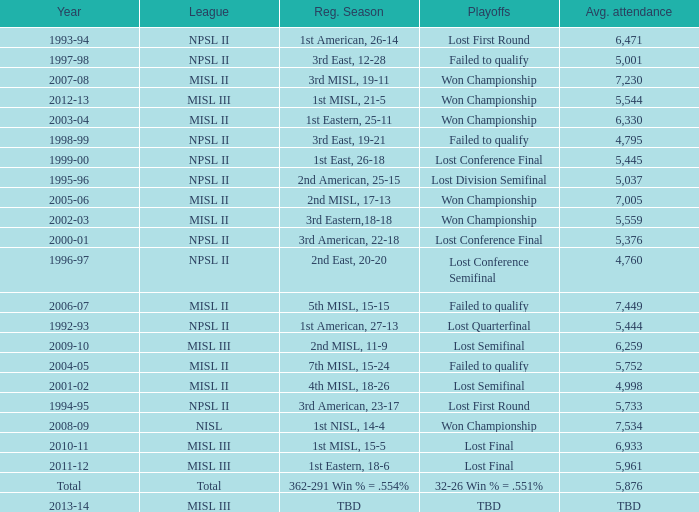When was the year that had an average attendance of 5,445? 1999-00. 